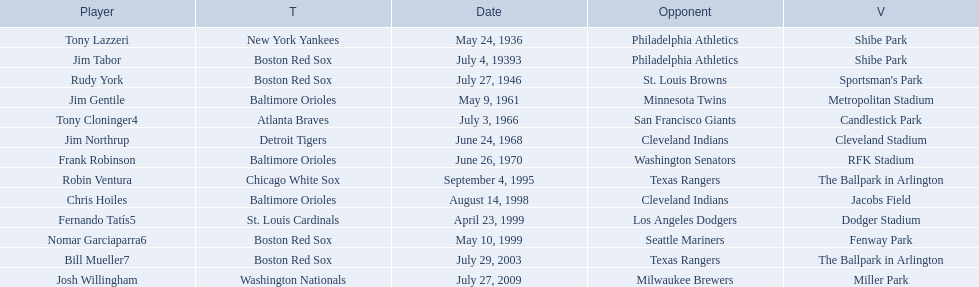Who are all the opponents? Philadelphia Athletics, Philadelphia Athletics, St. Louis Browns, Minnesota Twins, San Francisco Giants, Cleveland Indians, Washington Senators, Texas Rangers, Cleveland Indians, Los Angeles Dodgers, Seattle Mariners, Texas Rangers, Milwaukee Brewers. What teams played on july 27, 1946? Boston Red Sox, July 27, 1946, St. Louis Browns. Who was the opponent in this game? St. Louis Browns. 